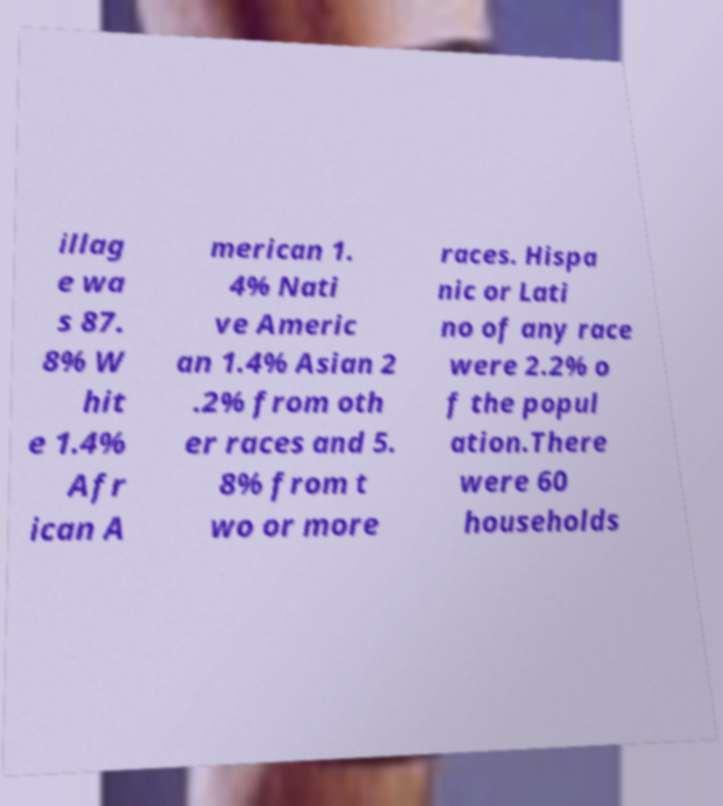Could you assist in decoding the text presented in this image and type it out clearly? illag e wa s 87. 8% W hit e 1.4% Afr ican A merican 1. 4% Nati ve Americ an 1.4% Asian 2 .2% from oth er races and 5. 8% from t wo or more races. Hispa nic or Lati no of any race were 2.2% o f the popul ation.There were 60 households 